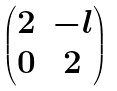<formula> <loc_0><loc_0><loc_500><loc_500>\begin{pmatrix} 2 & - l \\ 0 & 2 \\ \end{pmatrix}</formula> 